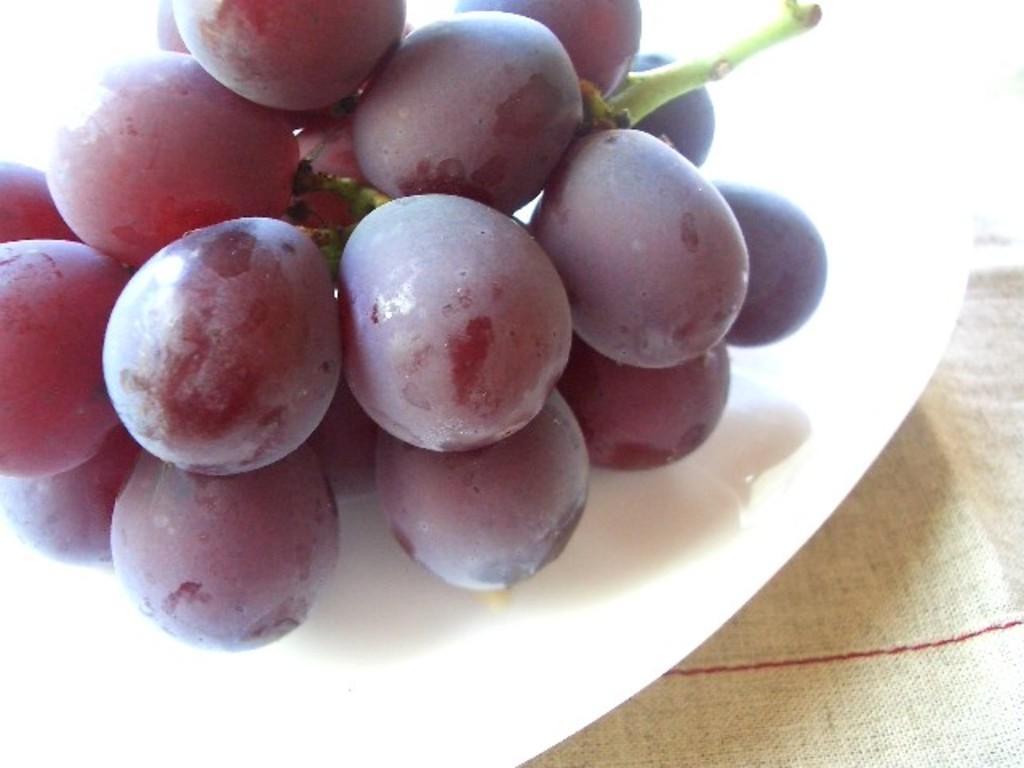Could you give a brief overview of what you see in this image? In this image there is a plate. On the plate where are grapes. At the bottom it looks like a mat. 